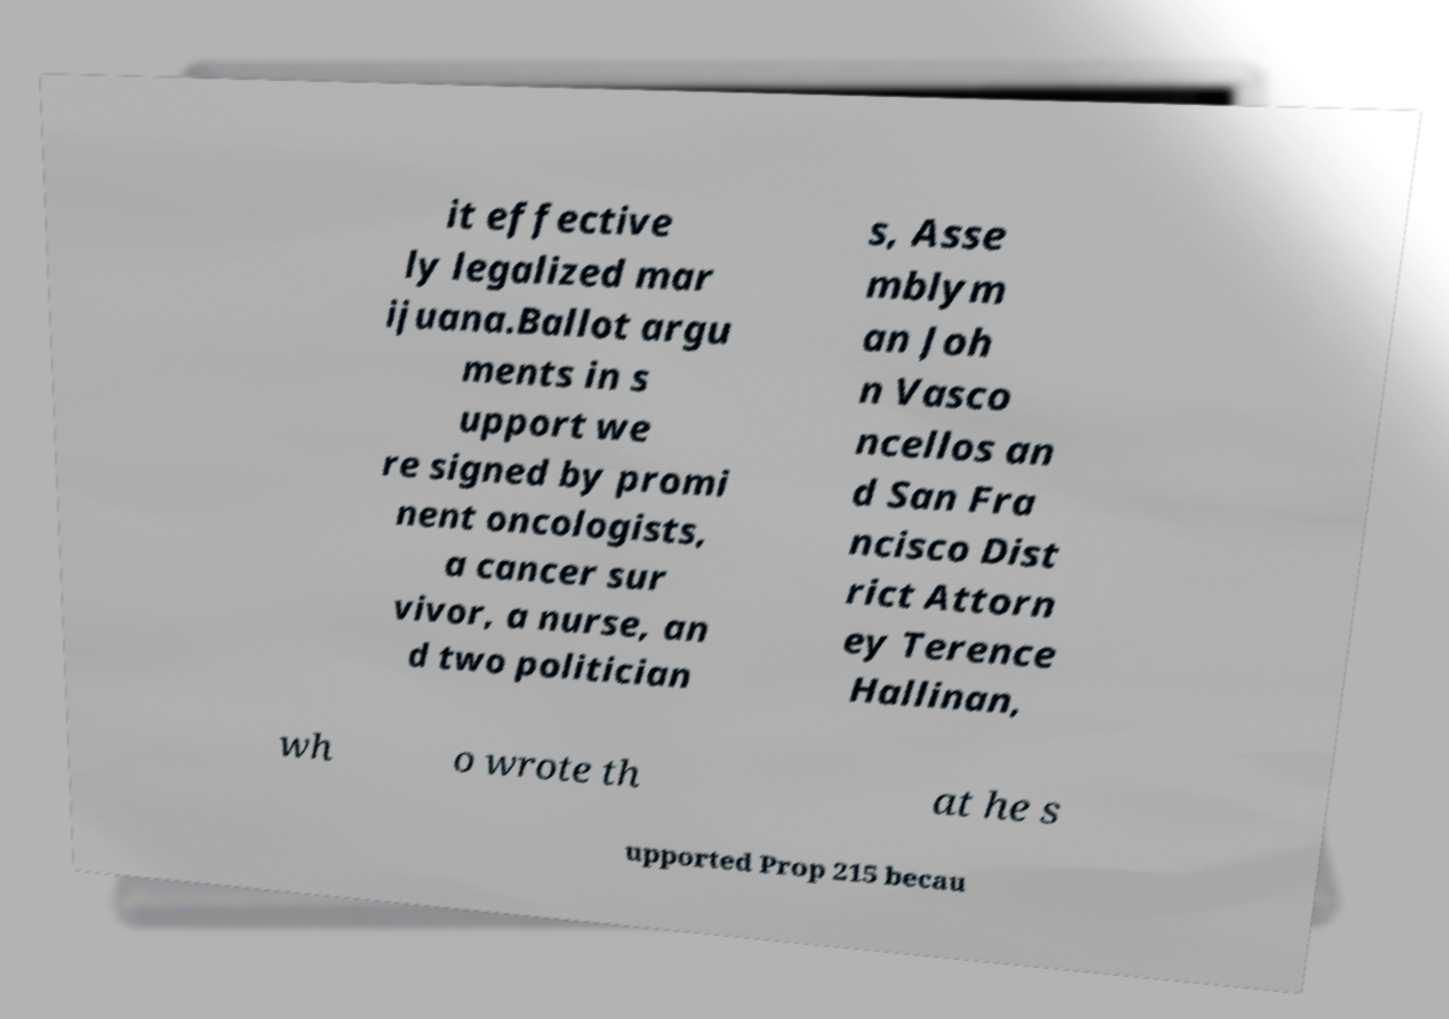There's text embedded in this image that I need extracted. Can you transcribe it verbatim? it effective ly legalized mar ijuana.Ballot argu ments in s upport we re signed by promi nent oncologists, a cancer sur vivor, a nurse, an d two politician s, Asse mblym an Joh n Vasco ncellos an d San Fra ncisco Dist rict Attorn ey Terence Hallinan, wh o wrote th at he s upported Prop 215 becau 